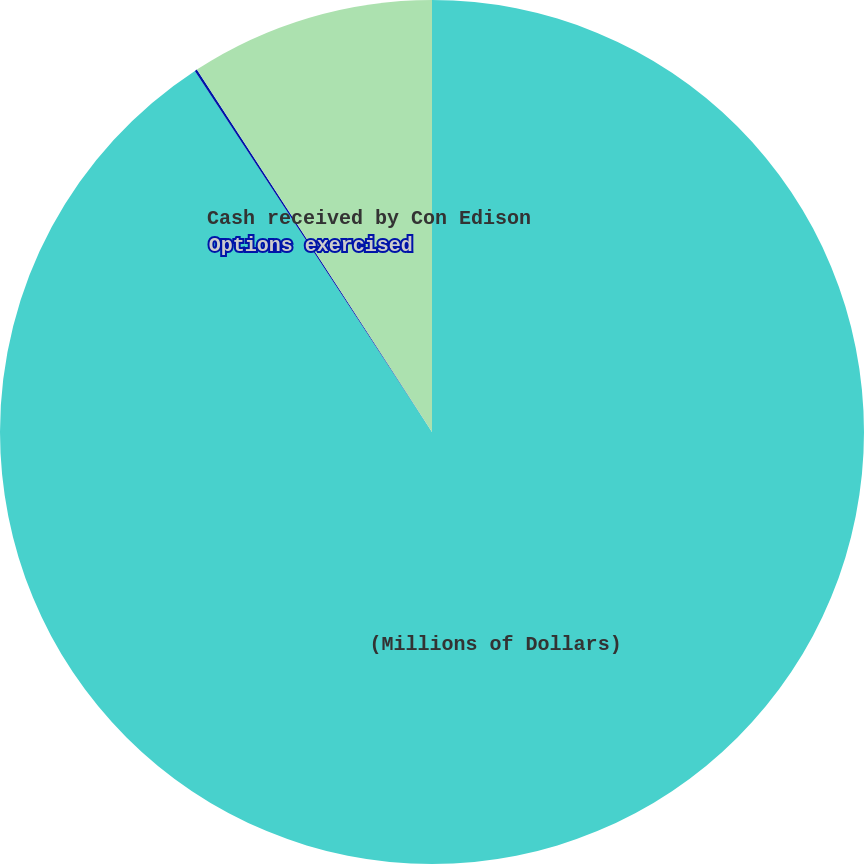<chart> <loc_0><loc_0><loc_500><loc_500><pie_chart><fcel>(Millions of Dollars)<fcel>Options exercised<fcel>Cash received by Con Edison<nl><fcel>90.75%<fcel>0.09%<fcel>9.16%<nl></chart> 